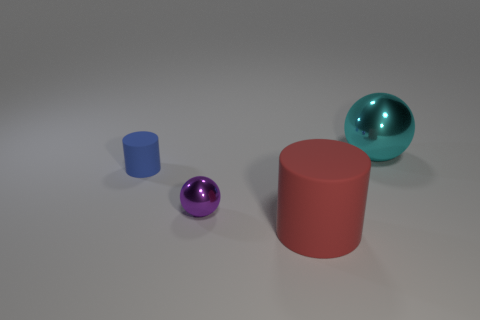What could be the significance of the color choices for these objects? Color choices in compositions like this can convey mood or emphasize contrast. Here, the vibrant red, purple, and blue are primary and secondary colors which provide a harmonious contrast. Additionally, the glossy red and purple against the matte blue create a visual interest, guiding the viewer's eye through the composition. 